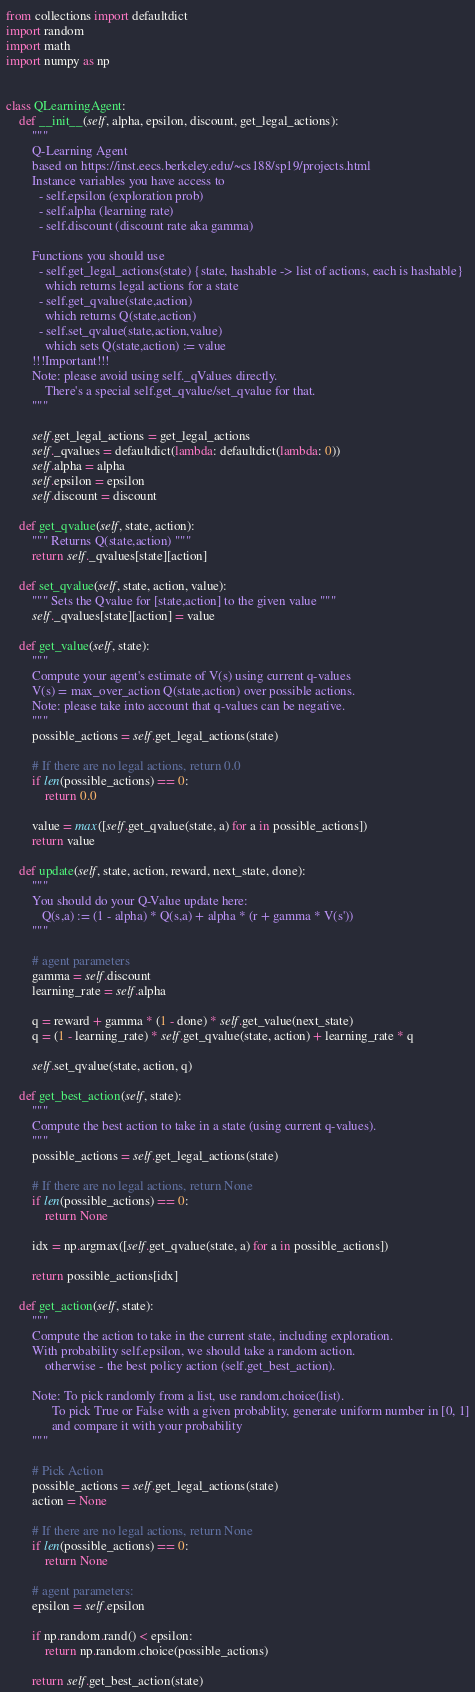Convert code to text. <code><loc_0><loc_0><loc_500><loc_500><_Python_>from collections import defaultdict
import random
import math
import numpy as np


class QLearningAgent:
    def __init__(self, alpha, epsilon, discount, get_legal_actions):
        """
        Q-Learning Agent
        based on https://inst.eecs.berkeley.edu/~cs188/sp19/projects.html
        Instance variables you have access to
          - self.epsilon (exploration prob)
          - self.alpha (learning rate)
          - self.discount (discount rate aka gamma)

        Functions you should use
          - self.get_legal_actions(state) {state, hashable -> list of actions, each is hashable}
            which returns legal actions for a state
          - self.get_qvalue(state,action)
            which returns Q(state,action)
          - self.set_qvalue(state,action,value)
            which sets Q(state,action) := value
        !!!Important!!!
        Note: please avoid using self._qValues directly. 
            There's a special self.get_qvalue/set_qvalue for that.
        """

        self.get_legal_actions = get_legal_actions
        self._qvalues = defaultdict(lambda: defaultdict(lambda: 0))
        self.alpha = alpha
        self.epsilon = epsilon
        self.discount = discount

    def get_qvalue(self, state, action):
        """ Returns Q(state,action) """
        return self._qvalues[state][action]

    def set_qvalue(self, state, action, value):
        """ Sets the Qvalue for [state,action] to the given value """
        self._qvalues[state][action] = value

    def get_value(self, state):
        """
        Compute your agent's estimate of V(s) using current q-values
        V(s) = max_over_action Q(state,action) over possible actions.
        Note: please take into account that q-values can be negative.
        """
        possible_actions = self.get_legal_actions(state)

        # If there are no legal actions, return 0.0
        if len(possible_actions) == 0:
            return 0.0

        value = max([self.get_qvalue(state, a) for a in possible_actions])
        return value

    def update(self, state, action, reward, next_state, done):
        """
        You should do your Q-Value update here:
           Q(s,a) := (1 - alpha) * Q(s,a) + alpha * (r + gamma * V(s'))
        """

        # agent parameters
        gamma = self.discount
        learning_rate = self.alpha
        
        q = reward + gamma * (1 - done) * self.get_value(next_state)
        q = (1 - learning_rate) * self.get_qvalue(state, action) + learning_rate * q

        self.set_qvalue(state, action, q)

    def get_best_action(self, state):
        """
        Compute the best action to take in a state (using current q-values). 
        """
        possible_actions = self.get_legal_actions(state)

        # If there are no legal actions, return None
        if len(possible_actions) == 0:
            return None

        idx = np.argmax([self.get_qvalue(state, a) for a in possible_actions])

        return possible_actions[idx]

    def get_action(self, state):
        """
        Compute the action to take in the current state, including exploration.  
        With probability self.epsilon, we should take a random action.
            otherwise - the best policy action (self.get_best_action).

        Note: To pick randomly from a list, use random.choice(list). 
              To pick True or False with a given probablity, generate uniform number in [0, 1]
              and compare it with your probability
        """

        # Pick Action
        possible_actions = self.get_legal_actions(state)
        action = None

        # If there are no legal actions, return None
        if len(possible_actions) == 0:
            return None

        # agent parameters:
        epsilon = self.epsilon

        if np.random.rand() < epsilon:
            return np.random.choice(possible_actions)
        
        return self.get_best_action(state)</code> 